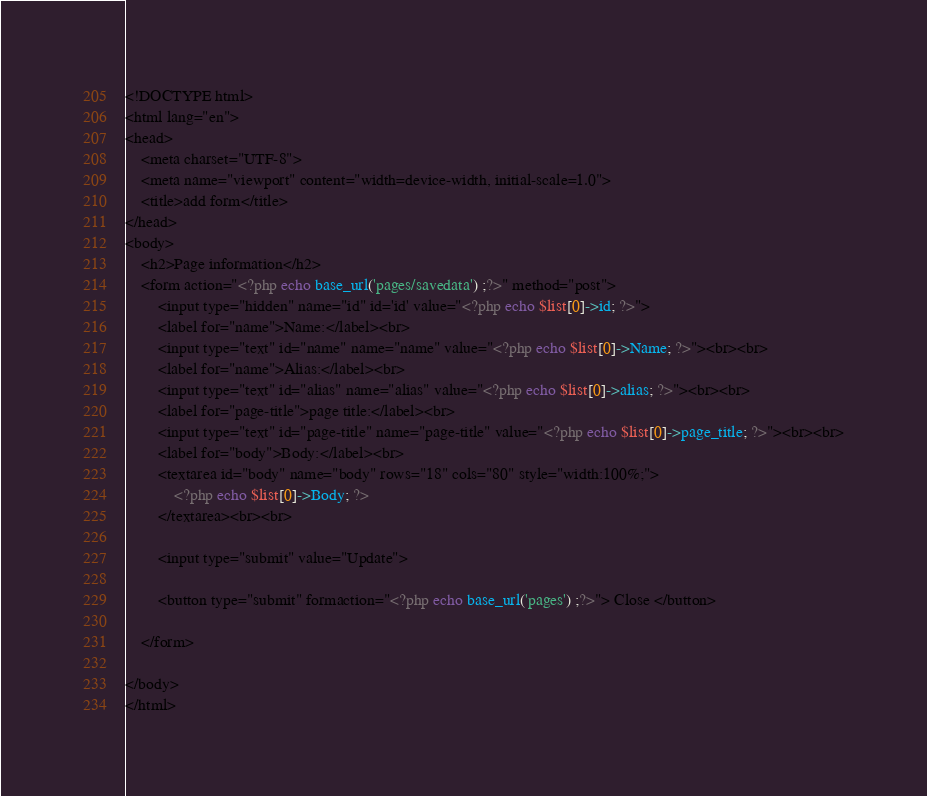<code> <loc_0><loc_0><loc_500><loc_500><_PHP_><!DOCTYPE html>
<html lang="en">
<head>
    <meta charset="UTF-8">
    <meta name="viewport" content="width=device-width, initial-scale=1.0">
    <title>add form</title>
</head>
<body>
    <h2>Page information</h2>
    <form action="<?php echo base_url('pages/savedata') ;?>" method="post">
        <input type="hidden" name="id" id='id' value="<?php echo $list[0]->id; ?>">
        <label for="name">Name:</label><br>
        <input type="text" id="name" name="name" value="<?php echo $list[0]->Name; ?>"><br><br>
        <label for="name">Alias:</label><br>
        <input type="text" id="alias" name="alias" value="<?php echo $list[0]->alias; ?>"><br><br>
        <label for="page-title">page title:</label><br>
        <input type="text" id="page-title" name="page-title" value="<?php echo $list[0]->page_title; ?>"><br><br>
        <label for="body">Body:</label><br>
        <textarea id="body" name="body" rows="18" cols="80" style="width:100%;">
            <?php echo $list[0]->Body; ?>
        </textarea><br><br>

        <input type="submit" value="Update">

        <button type="submit" formaction="<?php echo base_url('pages') ;?>"> Close </button>

    </form>

</body>
</html></code> 